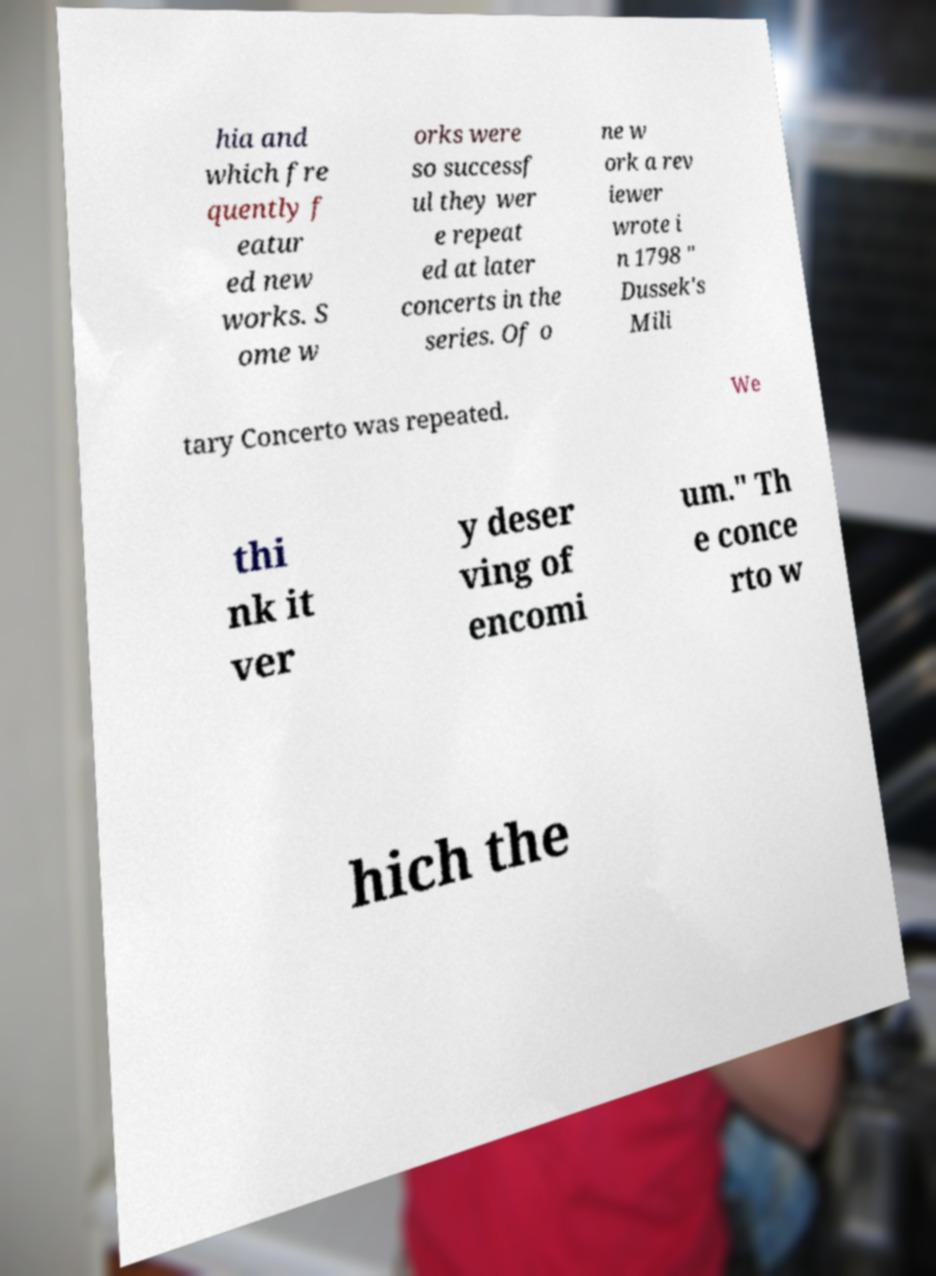Please read and relay the text visible in this image. What does it say? hia and which fre quently f eatur ed new works. S ome w orks were so successf ul they wer e repeat ed at later concerts in the series. Of o ne w ork a rev iewer wrote i n 1798 " Dussek's Mili tary Concerto was repeated. We thi nk it ver y deser ving of encomi um." Th e conce rto w hich the 